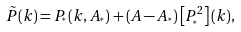Convert formula to latex. <formula><loc_0><loc_0><loc_500><loc_500>\tilde { P } ( k ) = P _ { ^ { * } } ( k , A _ { ^ { * } } ) + ( A - A _ { ^ { * } } ) \left [ P _ { ^ { * } } ^ { 2 } \right ] ( k ) ,</formula> 